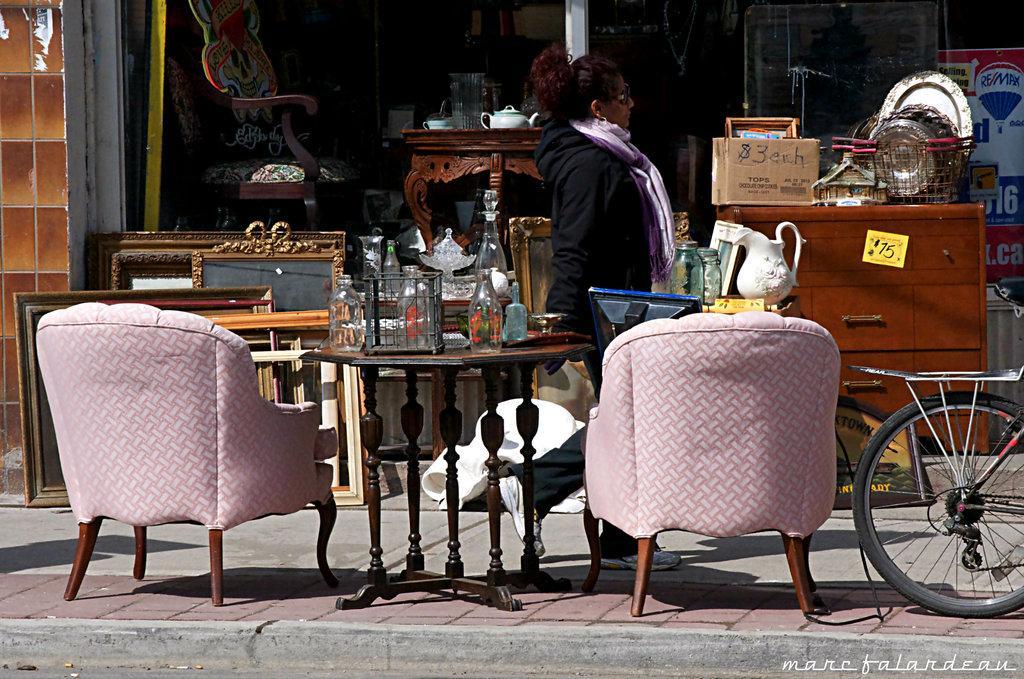Could you give a brief overview of what you see in this image? In this image there is a footpath, on that footpath there are chairs, in the middle there is a table, on that table there are bottles, in the background there are wooden furniture, a woman is walking on the footpath, on the right side there is a bicycle. 